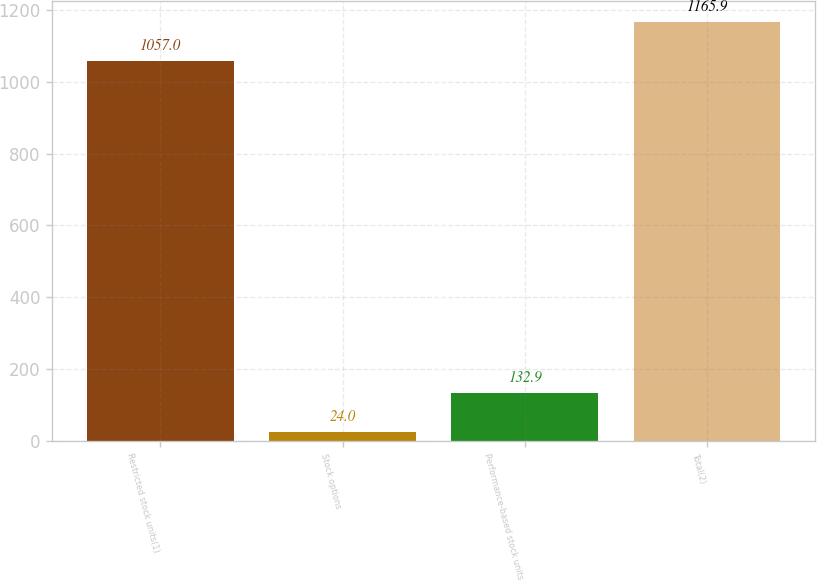Convert chart to OTSL. <chart><loc_0><loc_0><loc_500><loc_500><bar_chart><fcel>Restricted stock units(1)<fcel>Stock options<fcel>Performance-based stock units<fcel>Total(2)<nl><fcel>1057<fcel>24<fcel>132.9<fcel>1165.9<nl></chart> 